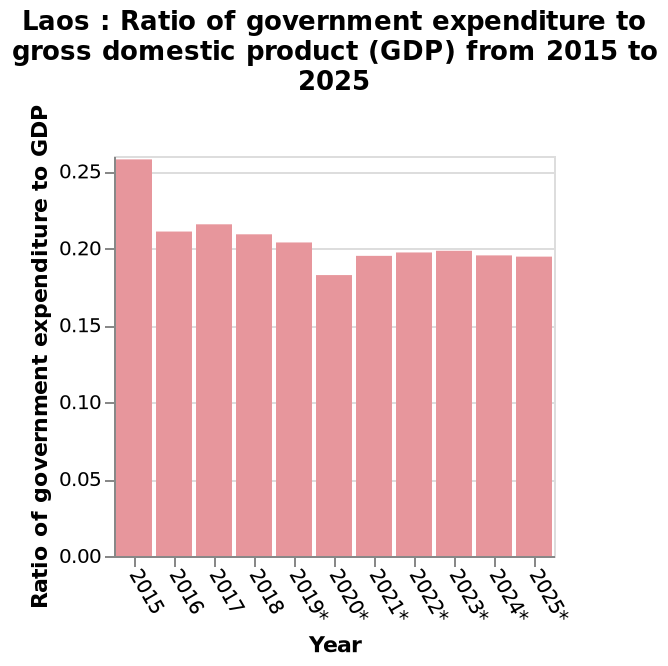<image>
What is the rate of increase in the figures shown on the chart? The rate of increase in the figures shown on the chart is slow. What is the highest figure shown on the chart?  The highest figure shown on the chart is 0.26 in 2015. What is the name of the bar graph?  The bar graph is named Laos: Ratio of government expenditure to gross domestic product (GDP) from 2015 to 2025. What is the scale used for the x-axis in the bar plot? The x-axis uses a categorical scale. 